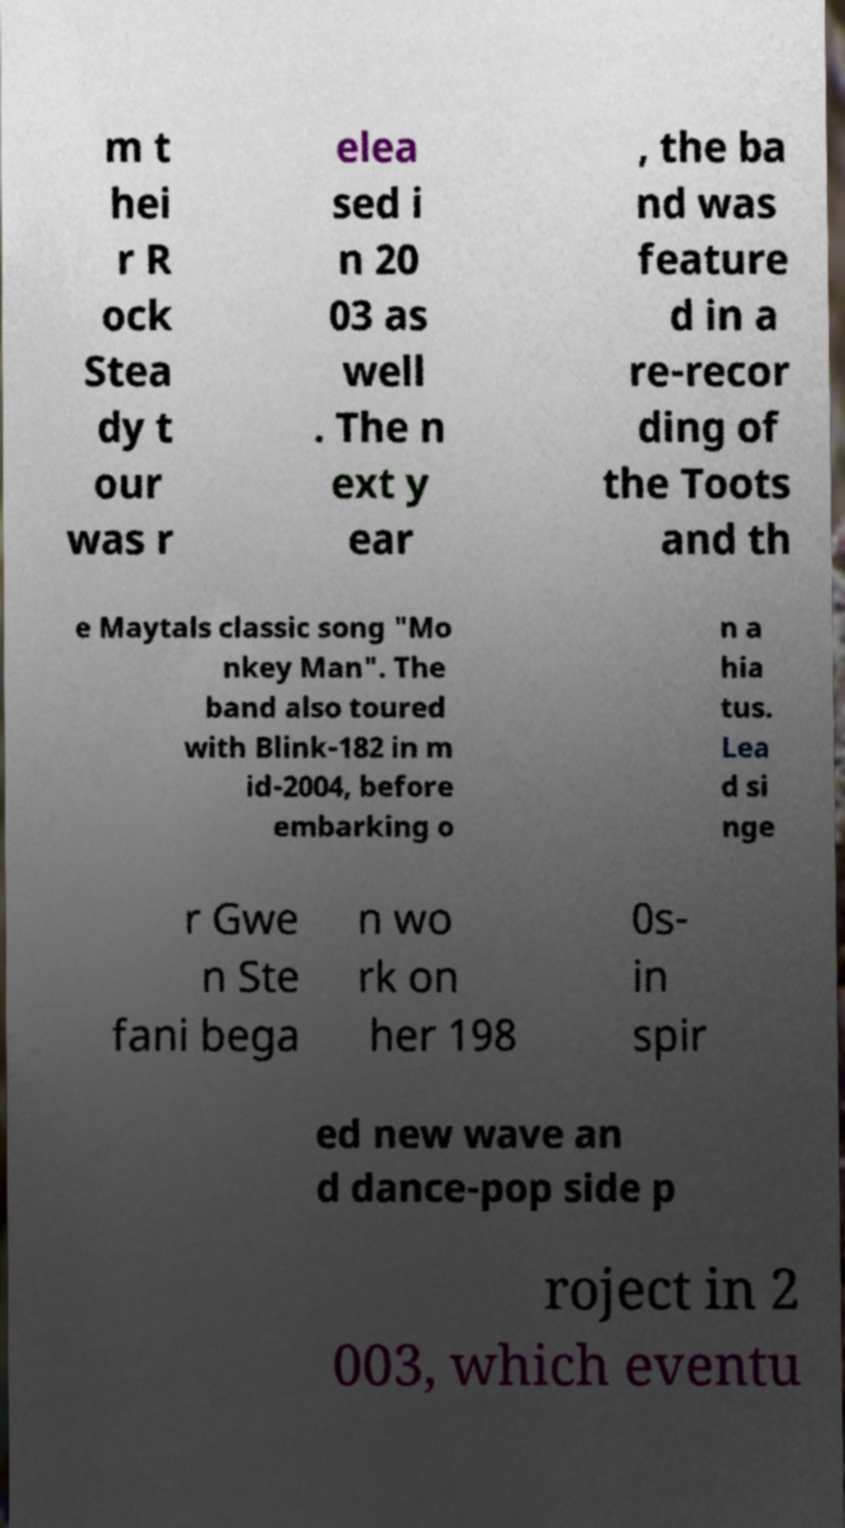Please identify and transcribe the text found in this image. m t hei r R ock Stea dy t our was r elea sed i n 20 03 as well . The n ext y ear , the ba nd was feature d in a re-recor ding of the Toots and th e Maytals classic song "Mo nkey Man". The band also toured with Blink-182 in m id-2004, before embarking o n a hia tus. Lea d si nge r Gwe n Ste fani bega n wo rk on her 198 0s- in spir ed new wave an d dance-pop side p roject in 2 003, which eventu 